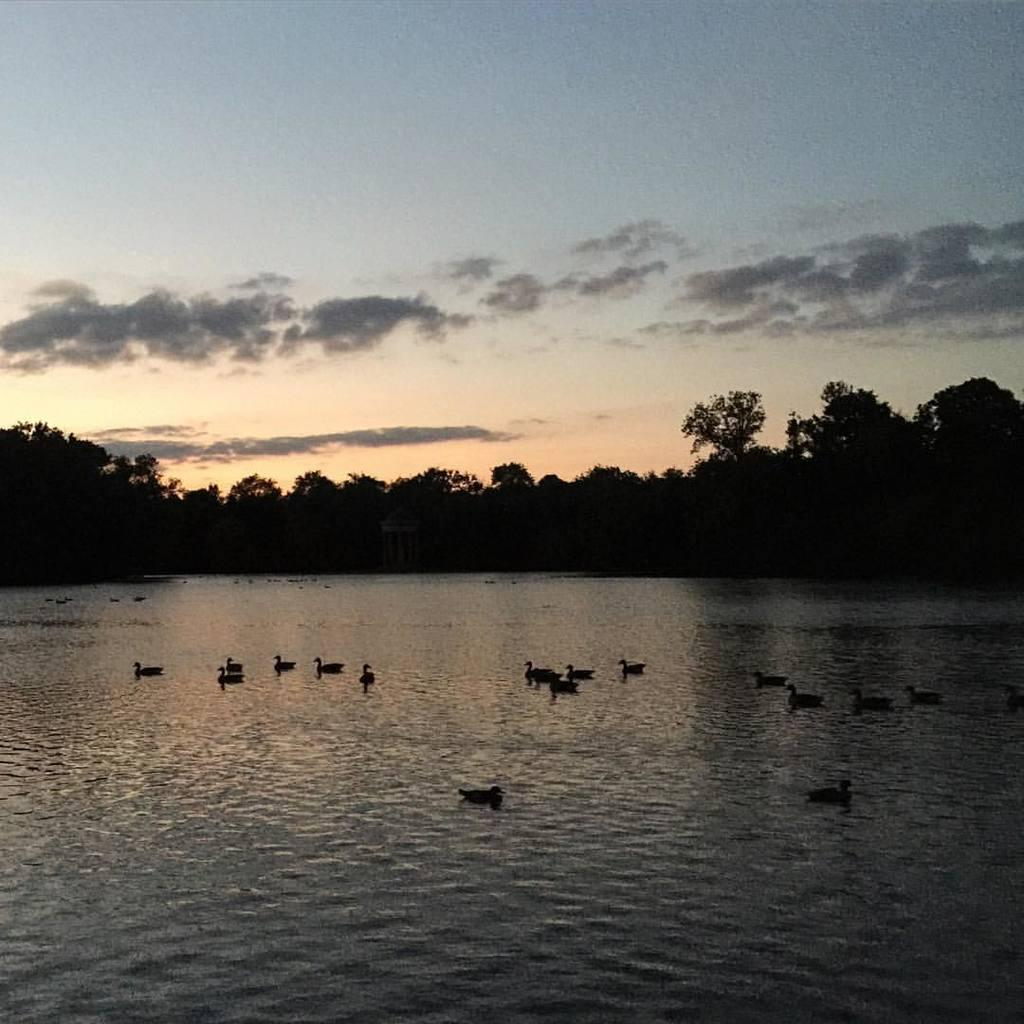What is present in the front of the image? There is water in the front of the image. What is on the water in the image? There are birds on the water. What can be seen in the background of the image? There are trees and clouds in the background of the image. What part of the natural environment is visible in the image? The sky is visible in the background of the image. What type of pencil can be seen hanging from the icicle in the image? There is no icicle or pencil present in the image. 